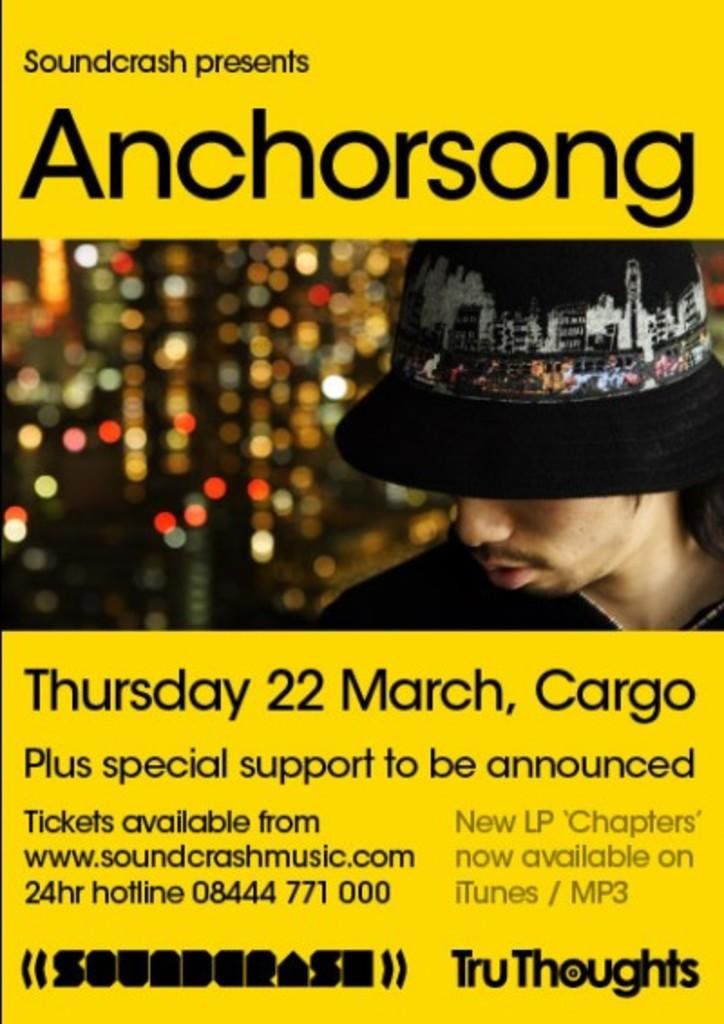What type of visual is the image? The image is a poster. Who or what is featured in the poster? There is a person depicted in the poster. What can be seen in the background of the poster? There are lights visible in the poster. Are there any words or phrases on the poster? Yes, there is text present in the poster. What is the person in the poster wearing on their head? The person in the poster is wearing a cap. What type of guitar is the person playing in the poster? There is no guitar present in the poster; the person is not depicted playing any instrument. What thought is the person having in the poster? There is no indication of the person's thoughts in the poster, as it does not show their facial expression or provide any context for their mental state. 